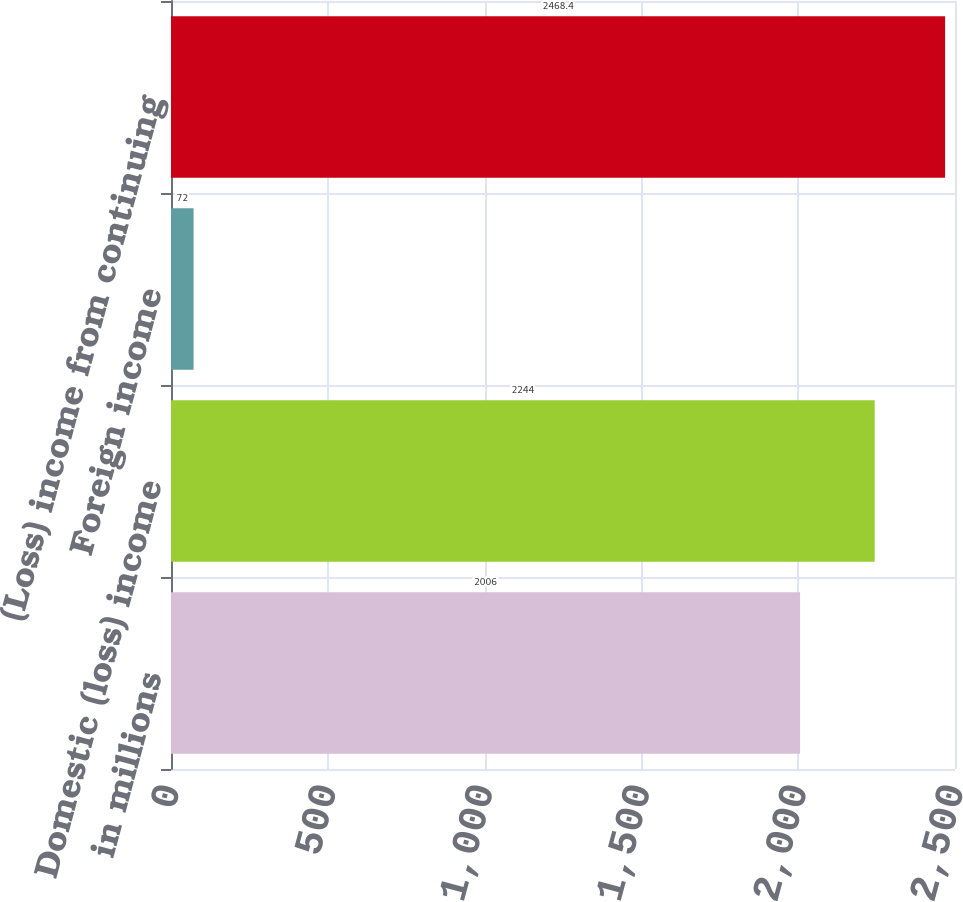Convert chart to OTSL. <chart><loc_0><loc_0><loc_500><loc_500><bar_chart><fcel>in millions<fcel>Domestic (loss) income<fcel>Foreign income<fcel>(Loss) income from continuing<nl><fcel>2006<fcel>2244<fcel>72<fcel>2468.4<nl></chart> 